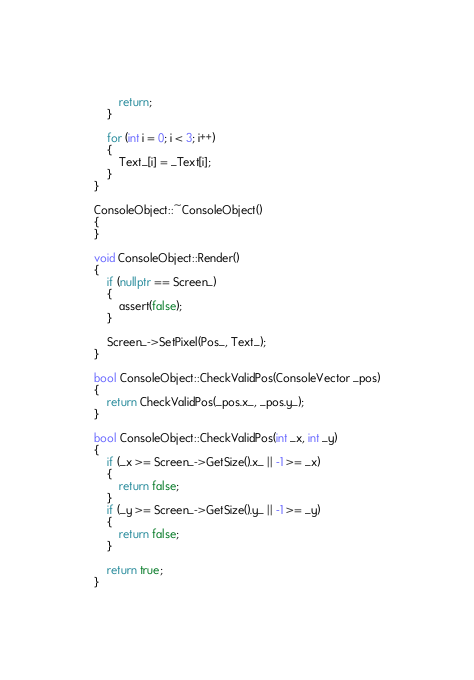<code> <loc_0><loc_0><loc_500><loc_500><_C++_>		return;
	}

	for (int i = 0; i < 3; i++)
	{
		Text_[i] = _Text[i];
	}
}

ConsoleObject::~ConsoleObject() 
{
}

void ConsoleObject::Render() 
{
	if (nullptr == Screen_)
	{
		assert(false);
	}

	Screen_->SetPixel(Pos_, Text_);
}

bool ConsoleObject::CheckValidPos(ConsoleVector _pos)
{
	return CheckValidPos(_pos.x_, _pos.y_);
}

bool ConsoleObject::CheckValidPos(int _x, int _y)
{
	if (_x >= Screen_->GetSize().x_ || -1 >= _x)
	{
		return false;
	}
	if (_y >= Screen_->GetSize().y_ || -1 >= _y)
	{
		return false;
	}

	return true;
}
</code> 